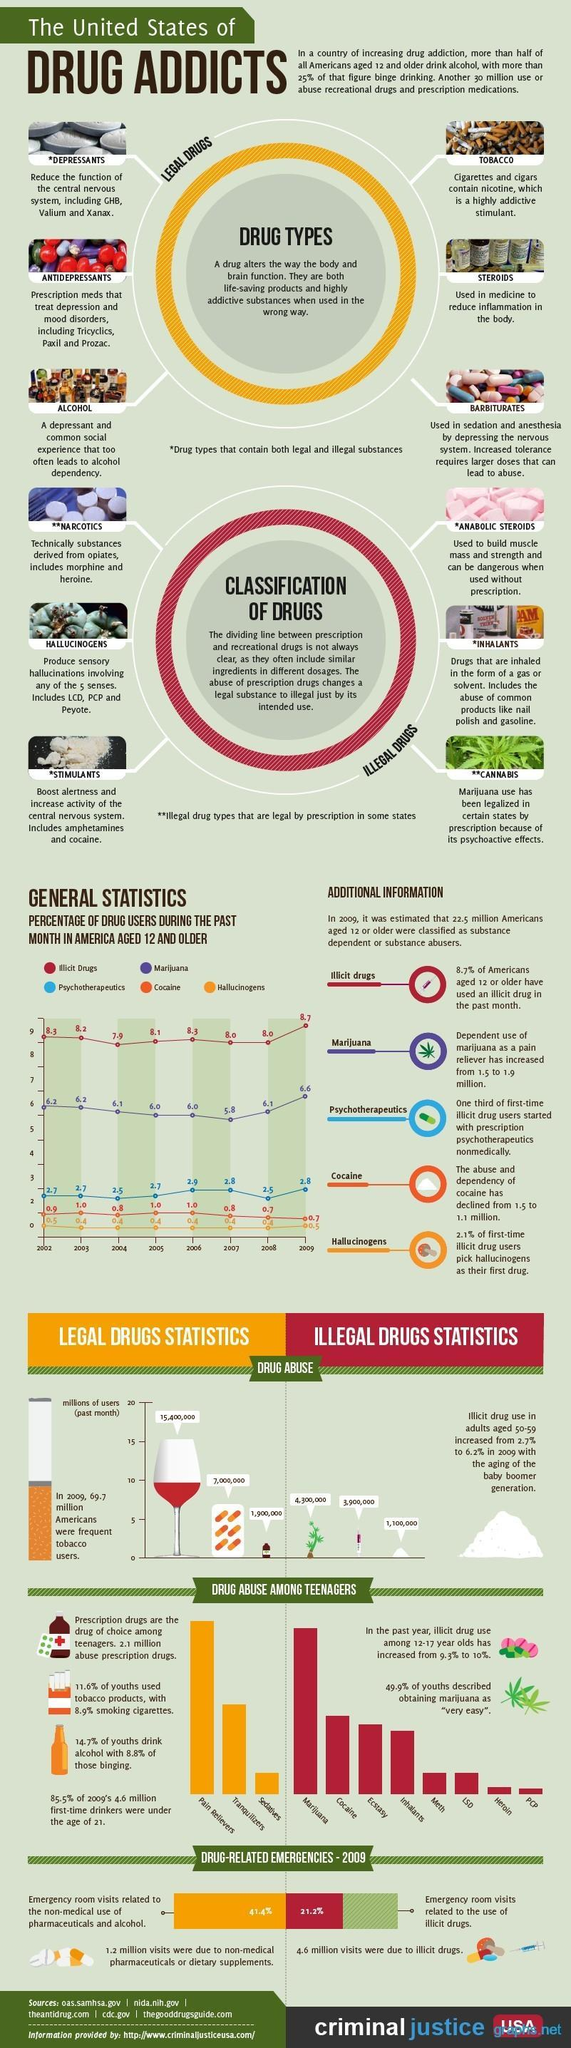Which is the drug that decreases the activity of central nervous system?
Answer the question with a short phrase. Depressants What is the percentage of drug users using Marijuana in the year 2003? 6.2 In which year percentage of drug users using Psychotherapeutics is the highest? 2006 In which year percentage of drug users using Marijuana is the lowest? 2007 How many drugs are listed in legal drugs? 6 In which year percentage of drug users using Illicit drug is the highest? 2009 Which is the drug that increases the activity of central nervous system? stimulants What is the percentage of drug users using Psychotherapeutics in the year 2008? 2.5 What is the percentage of drug users using Illicit drug in the year 2004? 7.9 Which is the drug that produces sensory hallucinations? Hallucinogens 